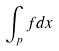<formula> <loc_0><loc_0><loc_500><loc_500>\int _ { p } f d x</formula> 